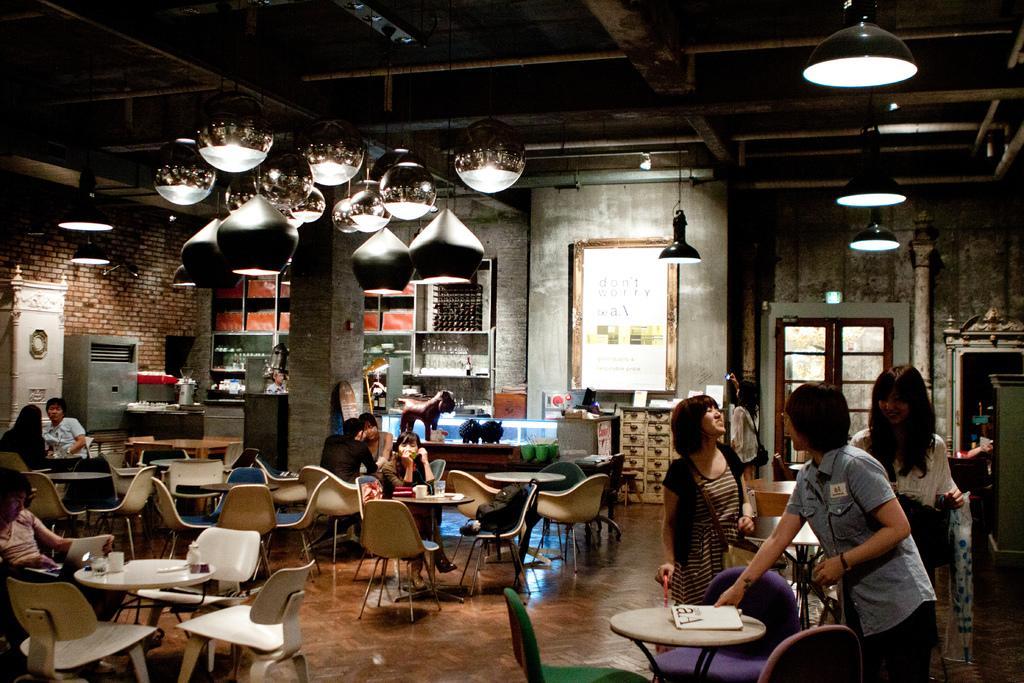How would you summarize this image in a sentence or two? In this image there are group of people some of them are sitting on a chair and some of them are standing and some tables are there. On the tables there are some glasses, tissue papers are there and on the top there is a ceiling and some lights are there and in the center there is a wall and on the right side there is a window and in the center there is one board on the wall. On the left side there is one box and some objects are there. 